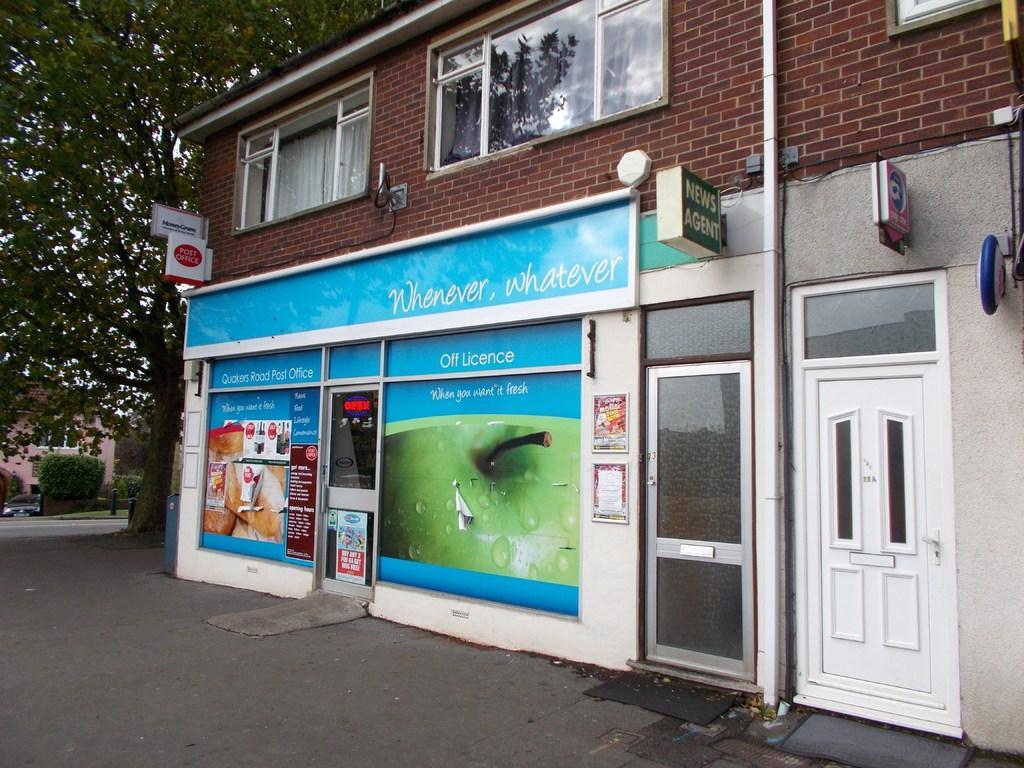In one or two sentences, can you explain what this image depicts? In this image, we can see some houses. Among them, we can see a house with windows, curtains and doors. We can also see some boards with text and images. We can see a tree and some plants. We can see a vehicle and the ground with some objects. 